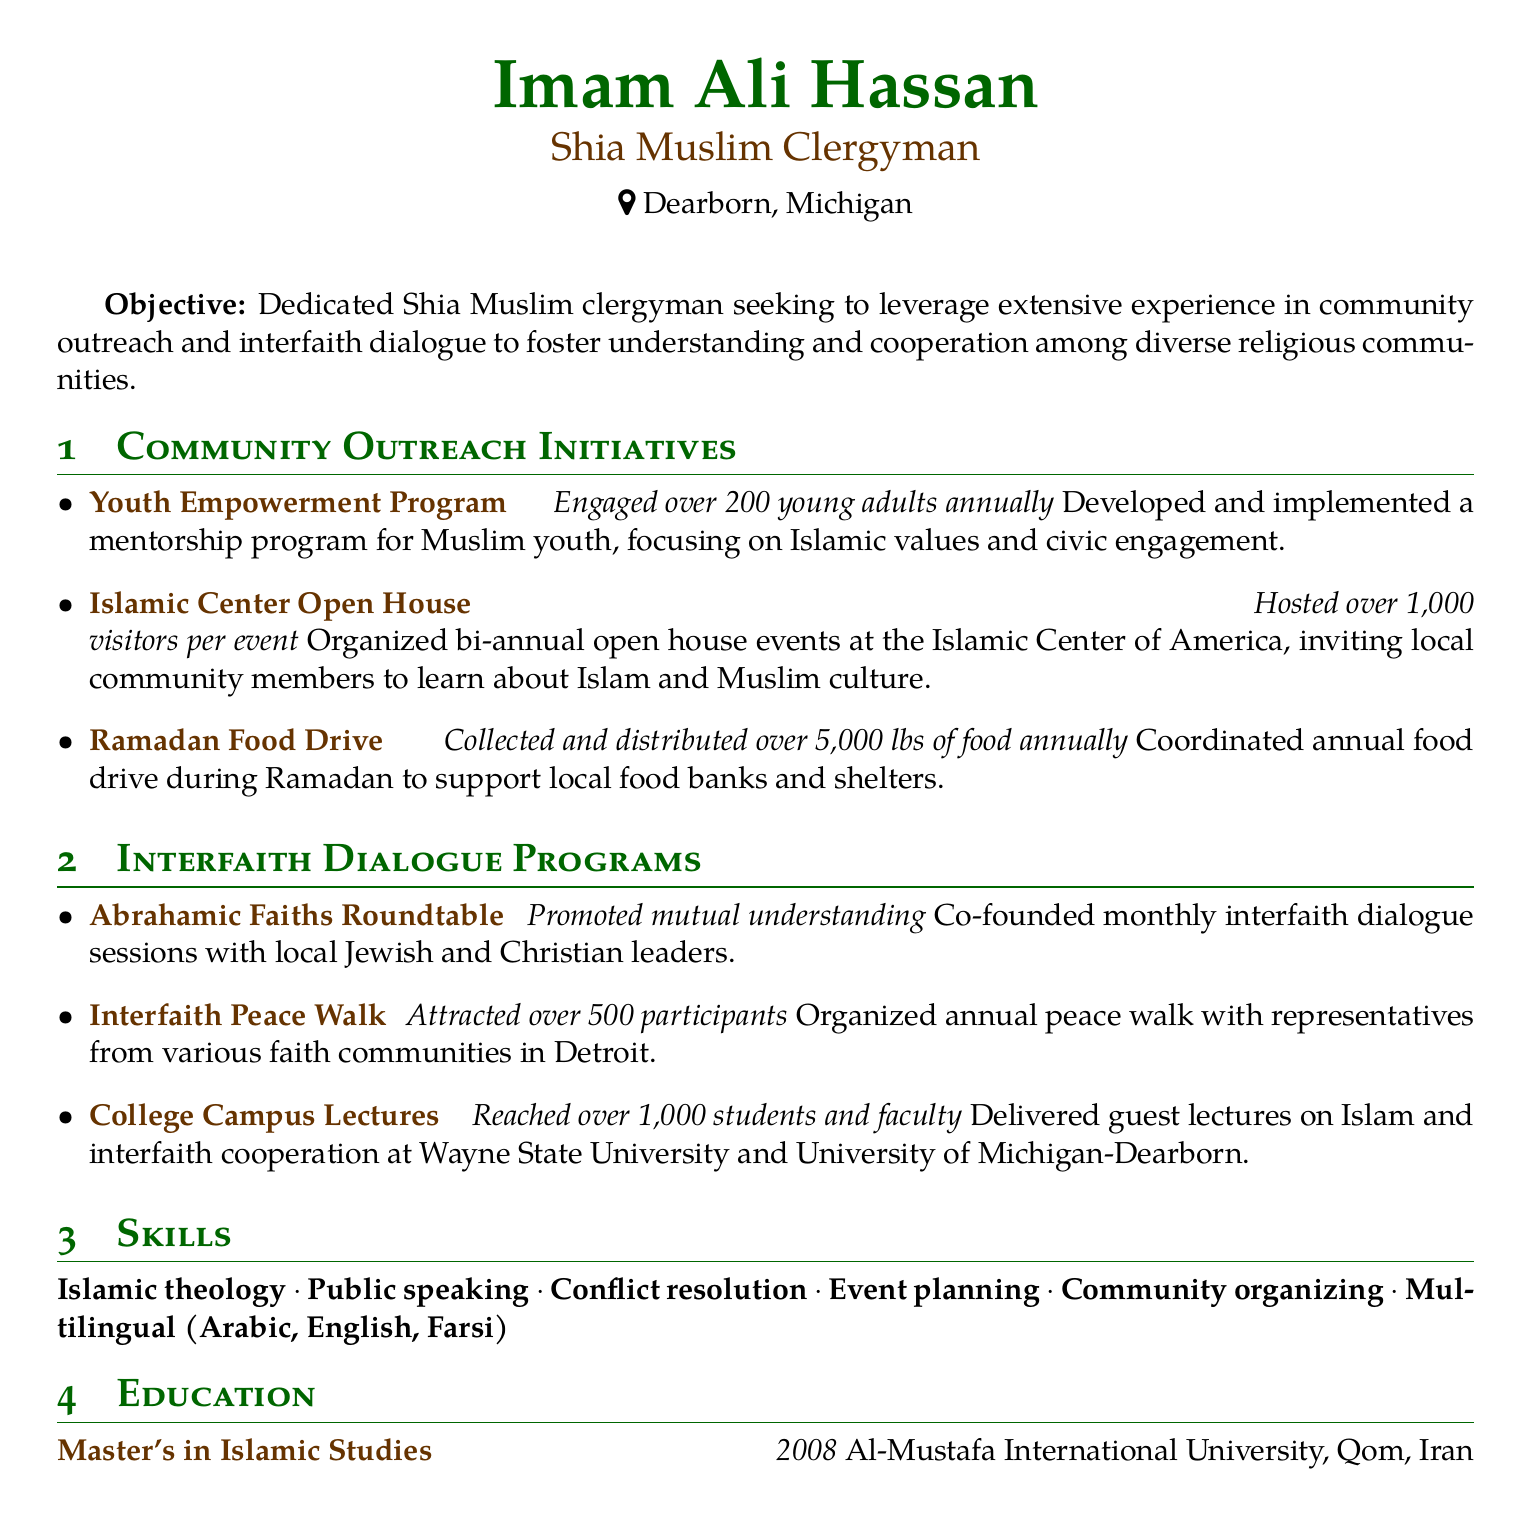what is the name of the clergyman? The name of the clergyman is presented at the top of the document as Imam Ali Hassan.
Answer: Imam Ali Hassan where is Imam Ali Hassan located? The location of Imam Ali Hassan is provided in the personal information section of the document.
Answer: Dearborn, Michigan what degree does Imam Ali Hassan hold? The document specifies the degree obtained by Imam Ali Hassan under the education section.
Answer: Master's in Islamic Studies what was the impact of the Youth Empowerment Program? This information is detailed in the community outreach section, highlighting the program's engagement level.
Answer: Engaged over 200 young adults annually how many participants were attracted to the Interfaith Peace Walk? The document mentions the number of participants in the interfaith dialogue section, specifically for the peace walk event.
Answer: Over 500 participants which university did Imam Ali Hassan deliver guest lectures at? The document lists the universities where guest lectures were delivered in the interfaith dialogue programs section.
Answer: Wayne State University and University of Michigan-Dearborn who were the participants in the Abrahamic Faiths Roundtable? The document explains the types of community leaders involved in this interfaith dialogue program.
Answer: Local Jewish and Christian leaders when did Imam Ali Hassan complete his degree? The education section specifies the year he completed his degree.
Answer: 2008 